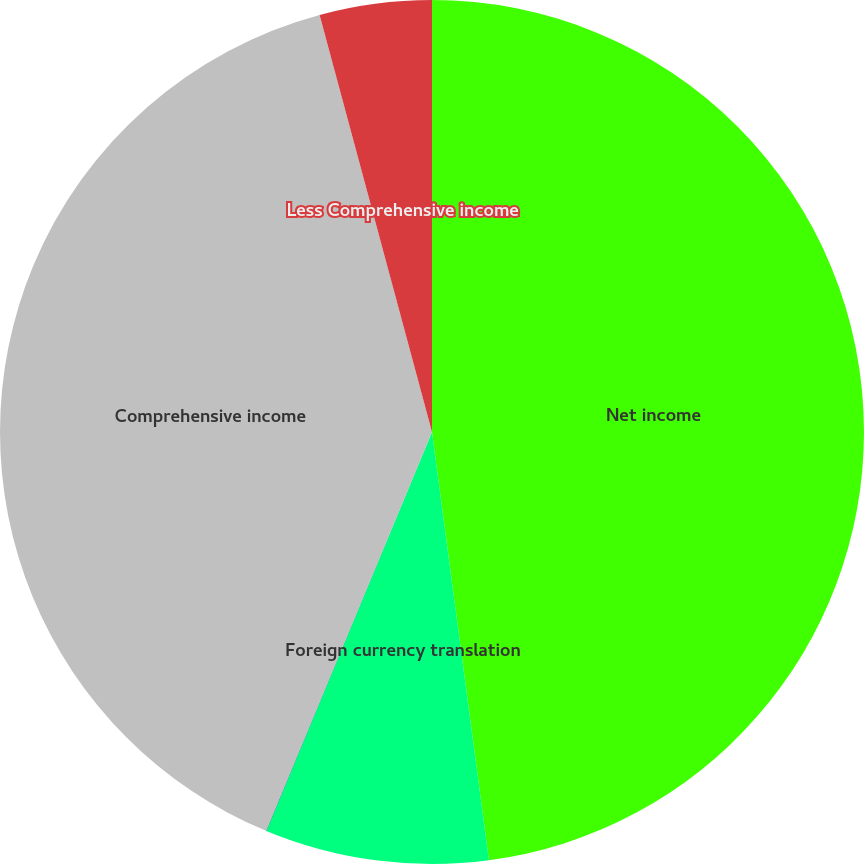<chart> <loc_0><loc_0><loc_500><loc_500><pie_chart><fcel>Net income<fcel>Foreign currency translation<fcel>Unrealized gain (loss) on<fcel>Comprehensive income<fcel>Less Comprehensive income<nl><fcel>47.9%<fcel>8.37%<fcel>0.01%<fcel>39.54%<fcel>4.19%<nl></chart> 